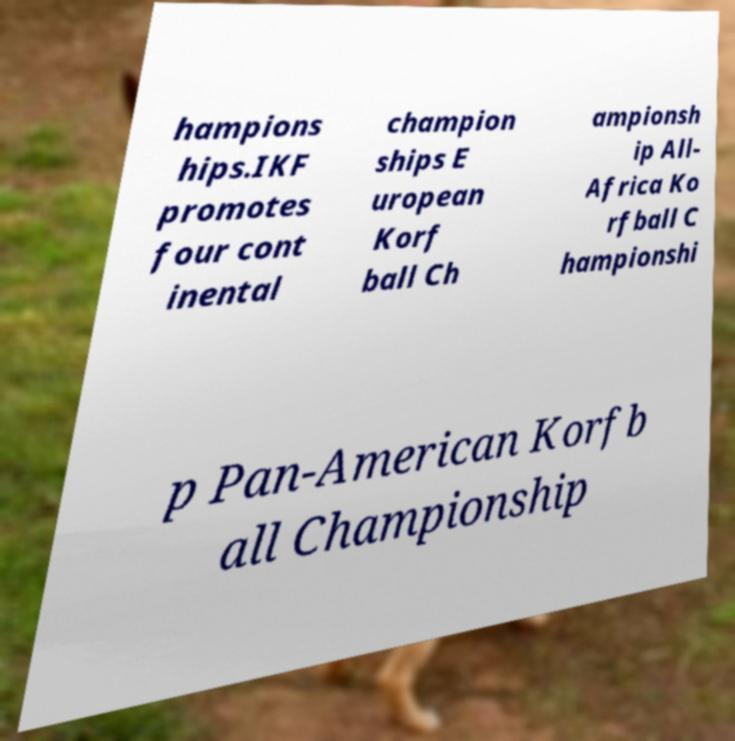Could you extract and type out the text from this image? hampions hips.IKF promotes four cont inental champion ships E uropean Korf ball Ch ampionsh ip All- Africa Ko rfball C hampionshi p Pan-American Korfb all Championship 